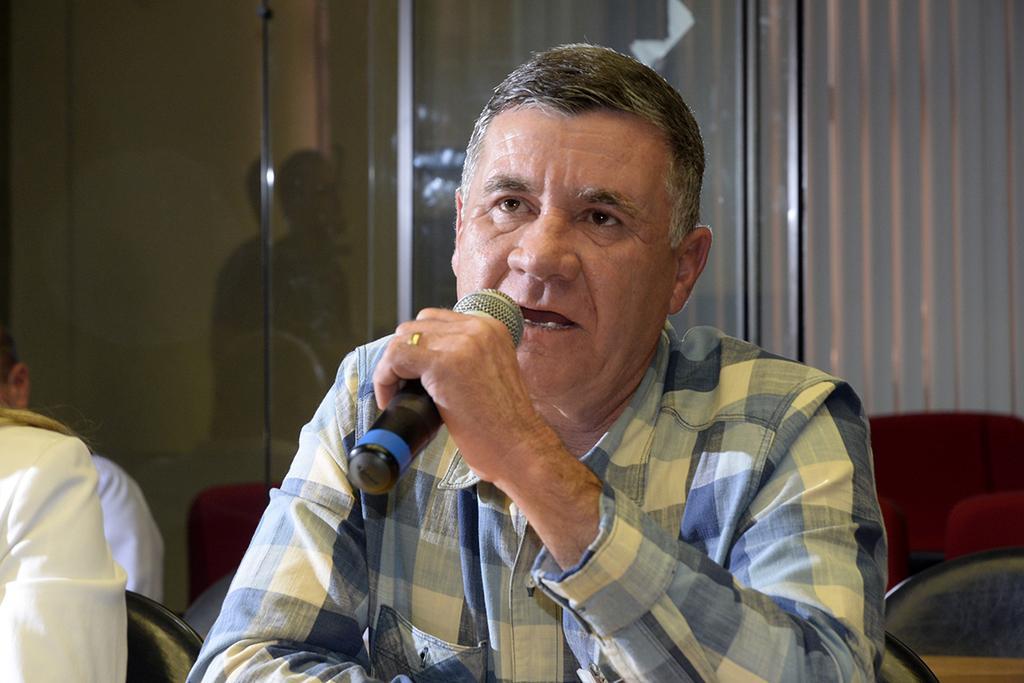Describe this image in one or two sentences. The person is sitting in a chair and speaking in front of a mic and there are two other persons sitting beside him. 